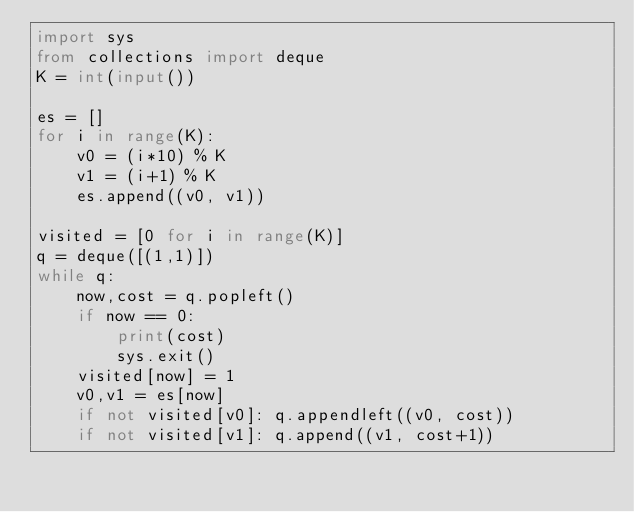<code> <loc_0><loc_0><loc_500><loc_500><_Python_>import sys
from collections import deque
K = int(input())

es = []
for i in range(K):
    v0 = (i*10) % K
    v1 = (i+1) % K
    es.append((v0, v1))

visited = [0 for i in range(K)]
q = deque([(1,1)])
while q:
    now,cost = q.popleft()
    if now == 0:
        print(cost)
        sys.exit()
    visited[now] = 1
    v0,v1 = es[now]
    if not visited[v0]: q.appendleft((v0, cost))
    if not visited[v1]: q.append((v1, cost+1))
</code> 